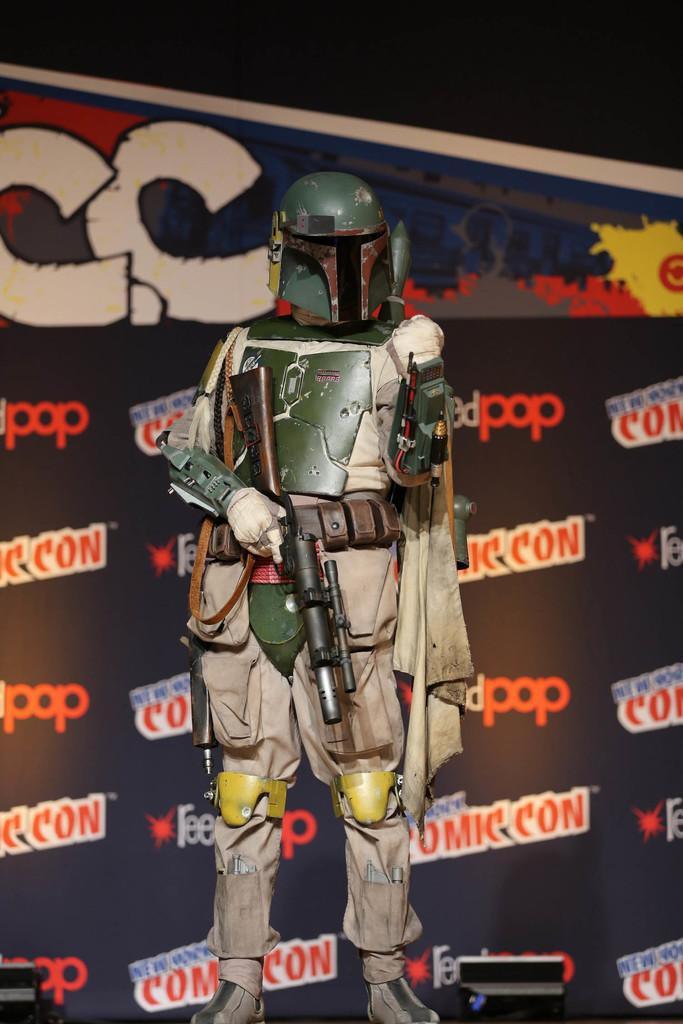What is the main subject of the image? There is a robot in the image. What is the robot holding? The robot is holding a gun. What color is the gun? The gun is black in color. How would you describe the robot's attire? The robot is wearing a white dress. What colors can be seen in the background of the image? The background of the image includes a wall with black, white, and red colors. What type of committee is responsible for the distribution of writing materials in the image? There is no committee or distribution of writing materials present in the image; it features a robot holding a gun and wearing a white dress. 